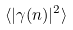Convert formula to latex. <formula><loc_0><loc_0><loc_500><loc_500>\langle | \gamma ( n ) | ^ { 2 } \rangle</formula> 